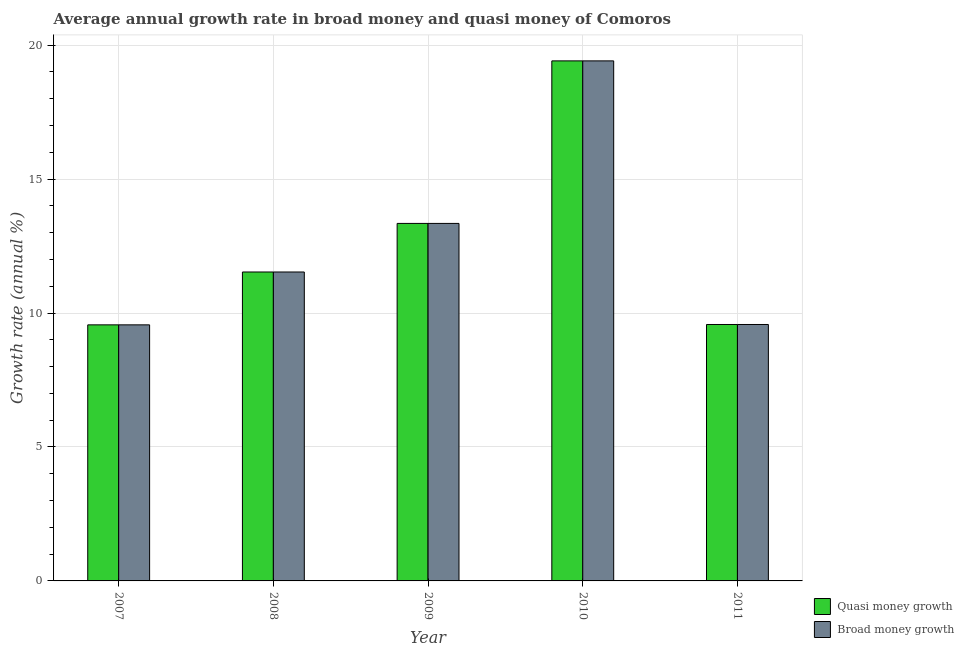How many different coloured bars are there?
Ensure brevity in your answer.  2. How many bars are there on the 1st tick from the right?
Ensure brevity in your answer.  2. What is the label of the 2nd group of bars from the left?
Ensure brevity in your answer.  2008. What is the annual growth rate in quasi money in 2008?
Your answer should be very brief. 11.53. Across all years, what is the maximum annual growth rate in broad money?
Give a very brief answer. 19.41. Across all years, what is the minimum annual growth rate in quasi money?
Provide a succinct answer. 9.56. In which year was the annual growth rate in broad money minimum?
Provide a short and direct response. 2007. What is the total annual growth rate in broad money in the graph?
Provide a short and direct response. 63.42. What is the difference between the annual growth rate in broad money in 2007 and that in 2011?
Keep it short and to the point. -0.01. What is the difference between the annual growth rate in quasi money in 2011 and the annual growth rate in broad money in 2007?
Give a very brief answer. 0.01. What is the average annual growth rate in quasi money per year?
Your response must be concise. 12.68. What is the ratio of the annual growth rate in broad money in 2007 to that in 2009?
Your response must be concise. 0.72. Is the difference between the annual growth rate in broad money in 2008 and 2010 greater than the difference between the annual growth rate in quasi money in 2008 and 2010?
Make the answer very short. No. What is the difference between the highest and the second highest annual growth rate in quasi money?
Ensure brevity in your answer.  6.07. What is the difference between the highest and the lowest annual growth rate in broad money?
Your answer should be compact. 9.85. In how many years, is the annual growth rate in quasi money greater than the average annual growth rate in quasi money taken over all years?
Offer a terse response. 2. Is the sum of the annual growth rate in broad money in 2009 and 2010 greater than the maximum annual growth rate in quasi money across all years?
Offer a very short reply. Yes. What does the 2nd bar from the left in 2010 represents?
Provide a succinct answer. Broad money growth. What does the 1st bar from the right in 2008 represents?
Offer a terse response. Broad money growth. What is the difference between two consecutive major ticks on the Y-axis?
Offer a terse response. 5. Where does the legend appear in the graph?
Provide a succinct answer. Bottom right. What is the title of the graph?
Your answer should be compact. Average annual growth rate in broad money and quasi money of Comoros. Does "Under-five" appear as one of the legend labels in the graph?
Offer a terse response. No. What is the label or title of the Y-axis?
Your response must be concise. Growth rate (annual %). What is the Growth rate (annual %) in Quasi money growth in 2007?
Ensure brevity in your answer.  9.56. What is the Growth rate (annual %) of Broad money growth in 2007?
Your response must be concise. 9.56. What is the Growth rate (annual %) of Quasi money growth in 2008?
Offer a terse response. 11.53. What is the Growth rate (annual %) of Broad money growth in 2008?
Make the answer very short. 11.53. What is the Growth rate (annual %) of Quasi money growth in 2009?
Ensure brevity in your answer.  13.34. What is the Growth rate (annual %) of Broad money growth in 2009?
Your answer should be compact. 13.34. What is the Growth rate (annual %) of Quasi money growth in 2010?
Ensure brevity in your answer.  19.41. What is the Growth rate (annual %) of Broad money growth in 2010?
Your answer should be compact. 19.41. What is the Growth rate (annual %) in Quasi money growth in 2011?
Keep it short and to the point. 9.57. What is the Growth rate (annual %) in Broad money growth in 2011?
Keep it short and to the point. 9.57. Across all years, what is the maximum Growth rate (annual %) in Quasi money growth?
Give a very brief answer. 19.41. Across all years, what is the maximum Growth rate (annual %) of Broad money growth?
Keep it short and to the point. 19.41. Across all years, what is the minimum Growth rate (annual %) in Quasi money growth?
Provide a short and direct response. 9.56. Across all years, what is the minimum Growth rate (annual %) in Broad money growth?
Provide a succinct answer. 9.56. What is the total Growth rate (annual %) of Quasi money growth in the graph?
Your answer should be very brief. 63.42. What is the total Growth rate (annual %) in Broad money growth in the graph?
Provide a succinct answer. 63.42. What is the difference between the Growth rate (annual %) of Quasi money growth in 2007 and that in 2008?
Your response must be concise. -1.97. What is the difference between the Growth rate (annual %) of Broad money growth in 2007 and that in 2008?
Make the answer very short. -1.97. What is the difference between the Growth rate (annual %) of Quasi money growth in 2007 and that in 2009?
Your answer should be compact. -3.79. What is the difference between the Growth rate (annual %) of Broad money growth in 2007 and that in 2009?
Ensure brevity in your answer.  -3.79. What is the difference between the Growth rate (annual %) in Quasi money growth in 2007 and that in 2010?
Your answer should be compact. -9.85. What is the difference between the Growth rate (annual %) in Broad money growth in 2007 and that in 2010?
Your answer should be very brief. -9.85. What is the difference between the Growth rate (annual %) in Quasi money growth in 2007 and that in 2011?
Your response must be concise. -0.01. What is the difference between the Growth rate (annual %) of Broad money growth in 2007 and that in 2011?
Keep it short and to the point. -0.01. What is the difference between the Growth rate (annual %) of Quasi money growth in 2008 and that in 2009?
Provide a short and direct response. -1.81. What is the difference between the Growth rate (annual %) of Broad money growth in 2008 and that in 2009?
Keep it short and to the point. -1.81. What is the difference between the Growth rate (annual %) of Quasi money growth in 2008 and that in 2010?
Your answer should be compact. -7.88. What is the difference between the Growth rate (annual %) in Broad money growth in 2008 and that in 2010?
Offer a very short reply. -7.88. What is the difference between the Growth rate (annual %) of Quasi money growth in 2008 and that in 2011?
Offer a very short reply. 1.96. What is the difference between the Growth rate (annual %) of Broad money growth in 2008 and that in 2011?
Ensure brevity in your answer.  1.96. What is the difference between the Growth rate (annual %) of Quasi money growth in 2009 and that in 2010?
Give a very brief answer. -6.07. What is the difference between the Growth rate (annual %) in Broad money growth in 2009 and that in 2010?
Your answer should be compact. -6.07. What is the difference between the Growth rate (annual %) of Quasi money growth in 2009 and that in 2011?
Keep it short and to the point. 3.77. What is the difference between the Growth rate (annual %) in Broad money growth in 2009 and that in 2011?
Offer a terse response. 3.77. What is the difference between the Growth rate (annual %) in Quasi money growth in 2010 and that in 2011?
Ensure brevity in your answer.  9.84. What is the difference between the Growth rate (annual %) of Broad money growth in 2010 and that in 2011?
Provide a succinct answer. 9.84. What is the difference between the Growth rate (annual %) in Quasi money growth in 2007 and the Growth rate (annual %) in Broad money growth in 2008?
Your answer should be compact. -1.97. What is the difference between the Growth rate (annual %) of Quasi money growth in 2007 and the Growth rate (annual %) of Broad money growth in 2009?
Your answer should be compact. -3.79. What is the difference between the Growth rate (annual %) of Quasi money growth in 2007 and the Growth rate (annual %) of Broad money growth in 2010?
Offer a terse response. -9.85. What is the difference between the Growth rate (annual %) in Quasi money growth in 2007 and the Growth rate (annual %) in Broad money growth in 2011?
Your answer should be very brief. -0.01. What is the difference between the Growth rate (annual %) in Quasi money growth in 2008 and the Growth rate (annual %) in Broad money growth in 2009?
Give a very brief answer. -1.81. What is the difference between the Growth rate (annual %) of Quasi money growth in 2008 and the Growth rate (annual %) of Broad money growth in 2010?
Your answer should be very brief. -7.88. What is the difference between the Growth rate (annual %) in Quasi money growth in 2008 and the Growth rate (annual %) in Broad money growth in 2011?
Offer a terse response. 1.96. What is the difference between the Growth rate (annual %) in Quasi money growth in 2009 and the Growth rate (annual %) in Broad money growth in 2010?
Your response must be concise. -6.07. What is the difference between the Growth rate (annual %) in Quasi money growth in 2009 and the Growth rate (annual %) in Broad money growth in 2011?
Offer a terse response. 3.77. What is the difference between the Growth rate (annual %) in Quasi money growth in 2010 and the Growth rate (annual %) in Broad money growth in 2011?
Provide a succinct answer. 9.84. What is the average Growth rate (annual %) of Quasi money growth per year?
Make the answer very short. 12.68. What is the average Growth rate (annual %) in Broad money growth per year?
Your response must be concise. 12.68. In the year 2007, what is the difference between the Growth rate (annual %) in Quasi money growth and Growth rate (annual %) in Broad money growth?
Offer a terse response. 0. In the year 2011, what is the difference between the Growth rate (annual %) in Quasi money growth and Growth rate (annual %) in Broad money growth?
Your answer should be very brief. 0. What is the ratio of the Growth rate (annual %) in Quasi money growth in 2007 to that in 2008?
Your answer should be very brief. 0.83. What is the ratio of the Growth rate (annual %) of Broad money growth in 2007 to that in 2008?
Give a very brief answer. 0.83. What is the ratio of the Growth rate (annual %) of Quasi money growth in 2007 to that in 2009?
Your answer should be compact. 0.72. What is the ratio of the Growth rate (annual %) in Broad money growth in 2007 to that in 2009?
Provide a short and direct response. 0.72. What is the ratio of the Growth rate (annual %) in Quasi money growth in 2007 to that in 2010?
Make the answer very short. 0.49. What is the ratio of the Growth rate (annual %) of Broad money growth in 2007 to that in 2010?
Give a very brief answer. 0.49. What is the ratio of the Growth rate (annual %) in Quasi money growth in 2007 to that in 2011?
Offer a very short reply. 1. What is the ratio of the Growth rate (annual %) in Broad money growth in 2007 to that in 2011?
Provide a succinct answer. 1. What is the ratio of the Growth rate (annual %) of Quasi money growth in 2008 to that in 2009?
Make the answer very short. 0.86. What is the ratio of the Growth rate (annual %) of Broad money growth in 2008 to that in 2009?
Offer a very short reply. 0.86. What is the ratio of the Growth rate (annual %) in Quasi money growth in 2008 to that in 2010?
Keep it short and to the point. 0.59. What is the ratio of the Growth rate (annual %) of Broad money growth in 2008 to that in 2010?
Give a very brief answer. 0.59. What is the ratio of the Growth rate (annual %) of Quasi money growth in 2008 to that in 2011?
Offer a terse response. 1.2. What is the ratio of the Growth rate (annual %) in Broad money growth in 2008 to that in 2011?
Offer a very short reply. 1.2. What is the ratio of the Growth rate (annual %) of Quasi money growth in 2009 to that in 2010?
Provide a short and direct response. 0.69. What is the ratio of the Growth rate (annual %) of Broad money growth in 2009 to that in 2010?
Make the answer very short. 0.69. What is the ratio of the Growth rate (annual %) in Quasi money growth in 2009 to that in 2011?
Provide a succinct answer. 1.39. What is the ratio of the Growth rate (annual %) of Broad money growth in 2009 to that in 2011?
Make the answer very short. 1.39. What is the ratio of the Growth rate (annual %) of Quasi money growth in 2010 to that in 2011?
Keep it short and to the point. 2.03. What is the ratio of the Growth rate (annual %) in Broad money growth in 2010 to that in 2011?
Make the answer very short. 2.03. What is the difference between the highest and the second highest Growth rate (annual %) in Quasi money growth?
Give a very brief answer. 6.07. What is the difference between the highest and the second highest Growth rate (annual %) of Broad money growth?
Give a very brief answer. 6.07. What is the difference between the highest and the lowest Growth rate (annual %) in Quasi money growth?
Ensure brevity in your answer.  9.85. What is the difference between the highest and the lowest Growth rate (annual %) of Broad money growth?
Your response must be concise. 9.85. 